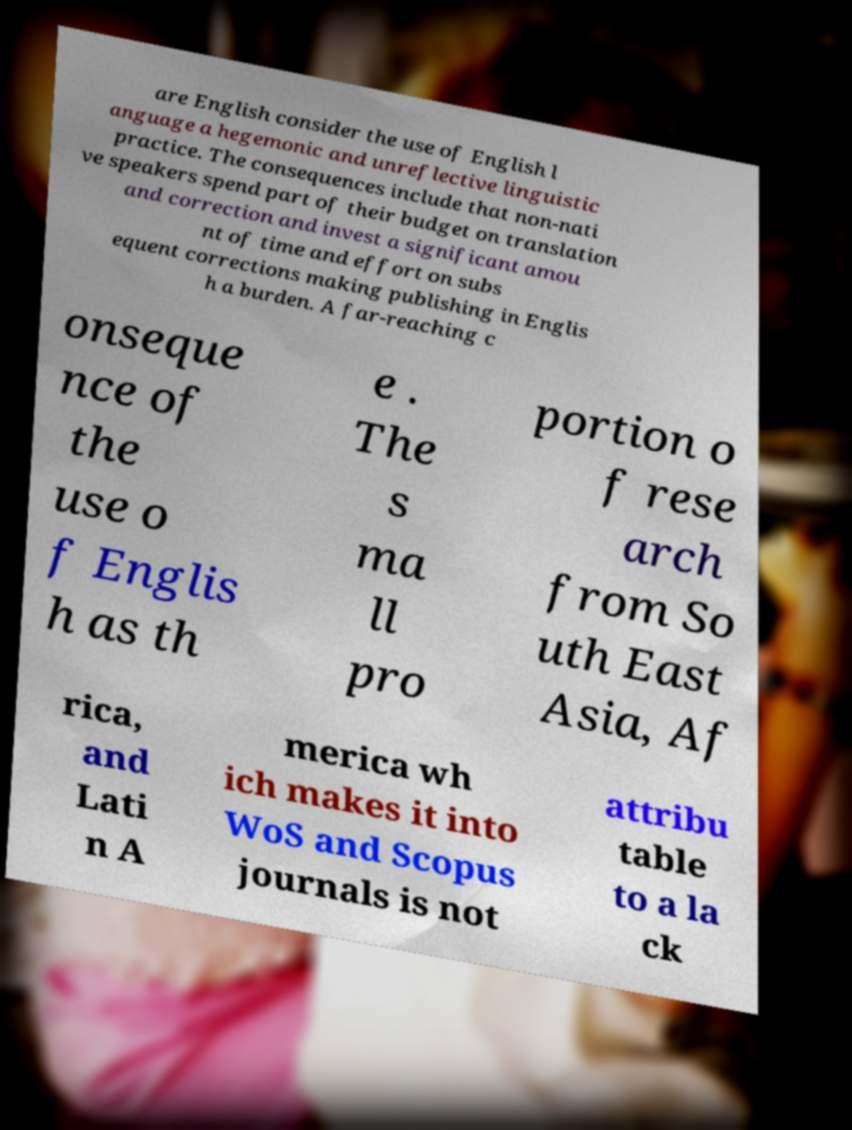Please identify and transcribe the text found in this image. are English consider the use of English l anguage a hegemonic and unreflective linguistic practice. The consequences include that non-nati ve speakers spend part of their budget on translation and correction and invest a significant amou nt of time and effort on subs equent corrections making publishing in Englis h a burden. A far-reaching c onseque nce of the use o f Englis h as th e . The s ma ll pro portion o f rese arch from So uth East Asia, Af rica, and Lati n A merica wh ich makes it into WoS and Scopus journals is not attribu table to a la ck 